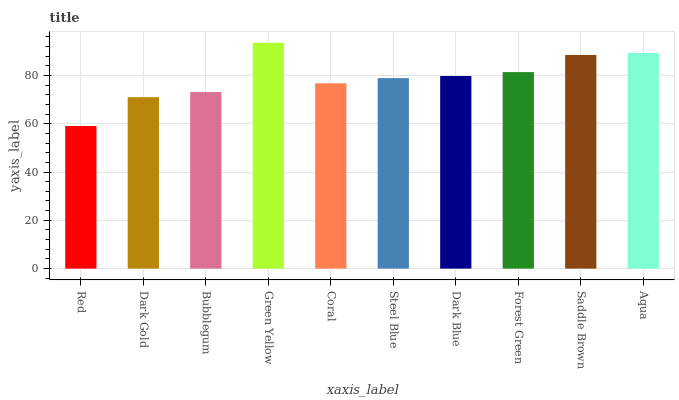Is Red the minimum?
Answer yes or no. Yes. Is Green Yellow the maximum?
Answer yes or no. Yes. Is Dark Gold the minimum?
Answer yes or no. No. Is Dark Gold the maximum?
Answer yes or no. No. Is Dark Gold greater than Red?
Answer yes or no. Yes. Is Red less than Dark Gold?
Answer yes or no. Yes. Is Red greater than Dark Gold?
Answer yes or no. No. Is Dark Gold less than Red?
Answer yes or no. No. Is Dark Blue the high median?
Answer yes or no. Yes. Is Steel Blue the low median?
Answer yes or no. Yes. Is Dark Gold the high median?
Answer yes or no. No. Is Saddle Brown the low median?
Answer yes or no. No. 